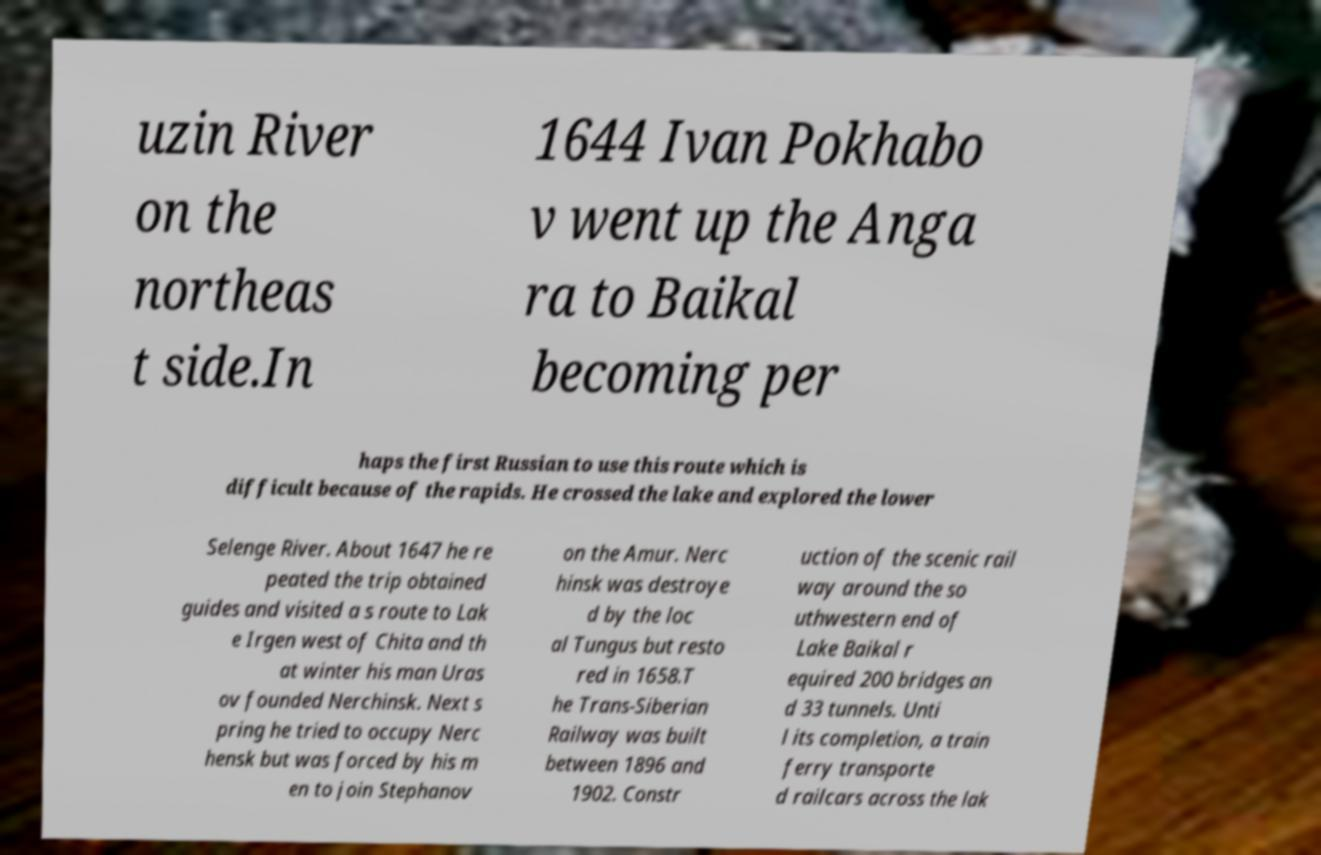There's text embedded in this image that I need extracted. Can you transcribe it verbatim? uzin River on the northeas t side.In 1644 Ivan Pokhabo v went up the Anga ra to Baikal becoming per haps the first Russian to use this route which is difficult because of the rapids. He crossed the lake and explored the lower Selenge River. About 1647 he re peated the trip obtained guides and visited a s route to Lak e Irgen west of Chita and th at winter his man Uras ov founded Nerchinsk. Next s pring he tried to occupy Nerc hensk but was forced by his m en to join Stephanov on the Amur. Nerc hinsk was destroye d by the loc al Tungus but resto red in 1658.T he Trans-Siberian Railway was built between 1896 and 1902. Constr uction of the scenic rail way around the so uthwestern end of Lake Baikal r equired 200 bridges an d 33 tunnels. Unti l its completion, a train ferry transporte d railcars across the lak 